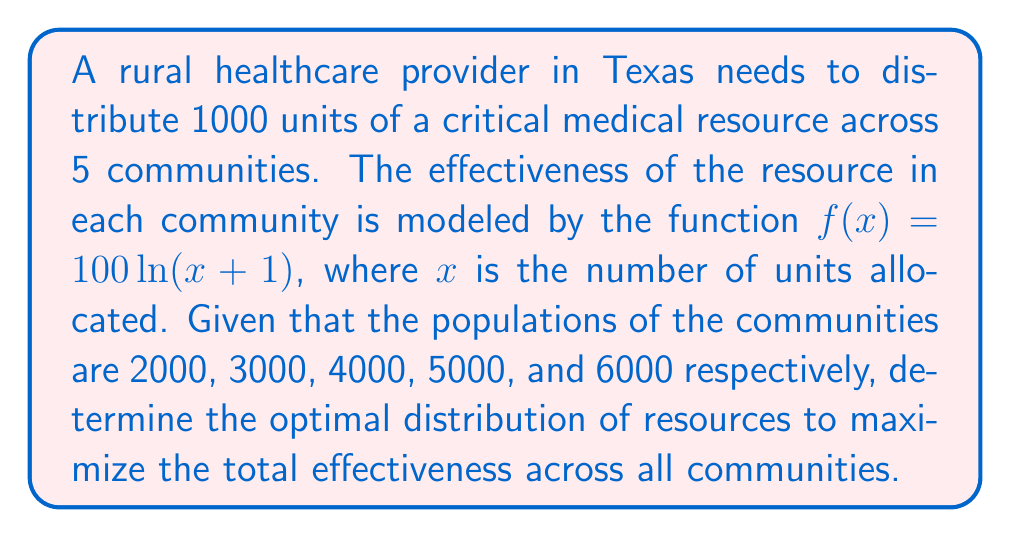Can you answer this question? To solve this problem, we'll use the method of Lagrange multipliers:

1) Let $x_1, x_2, x_3, x_4, x_5$ be the resources allocated to each community.

2) We want to maximize:
   $$F = 2000\ln(x_1+1) + 3000\ln(x_2+1) + 4000\ln(x_3+1) + 5000\ln(x_4+1) + 6000\ln(x_5+1)$$

3) Subject to the constraint:
   $$g = x_1 + x_2 + x_3 + x_4 + x_5 - 1000 = 0$$

4) Form the Lagrangian:
   $$L = F + \lambda g$$

5) Take partial derivatives and set them equal to zero:
   $$\frac{\partial L}{\partial x_1} = \frac{2000}{x_1+1} - \lambda = 0$$
   $$\frac{\partial L}{\partial x_2} = \frac{3000}{x_2+1} - \lambda = 0$$
   $$\frac{\partial L}{\partial x_3} = \frac{4000}{x_3+1} - \lambda = 0$$
   $$\frac{\partial L}{\partial x_4} = \frac{5000}{x_4+1} - \lambda = 0$$
   $$\frac{\partial L}{\partial x_5} = \frac{6000}{x_5+1} - \lambda = 0$$

6) From these equations, we can deduce:
   $$\frac{2000}{x_1+1} = \frac{3000}{x_2+1} = \frac{4000}{x_3+1} = \frac{5000}{x_4+1} = \frac{6000}{x_5+1}$$

7) This implies:
   $$x_1+1 = \frac{2000k}{1}, x_2+1 = \frac{3000k}{1}, x_3+1 = \frac{4000k}{1}, x_4+1 = \frac{5000k}{1}, x_5+1 = \frac{6000k}{1}$$
   where $k$ is a constant.

8) Substituting into the constraint equation:
   $$(2000k-1) + (3000k-1) + (4000k-1) + (5000k-1) + (6000k-1) = 1000$$
   $$20000k - 5 = 1000$$
   $$k = \frac{1005}{20000} = 0.05025$$

9) Now we can solve for each $x_i$:
   $$x_1 = 2000(0.05025) - 1 = 99.5$$
   $$x_2 = 3000(0.05025) - 1 = 149.75$$
   $$x_3 = 4000(0.05025) - 1 = 200$$
   $$x_4 = 5000(0.05025) - 1 = 250.25$$
   $$x_5 = 6000(0.05025) - 1 = 300.5$$

10) Rounding to the nearest whole number (as we can't distribute partial units):
    $x_1 = 100, x_2 = 150, x_3 = 200, x_4 = 250, x_5 = 300$
Answer: (100, 150, 200, 250, 300) 